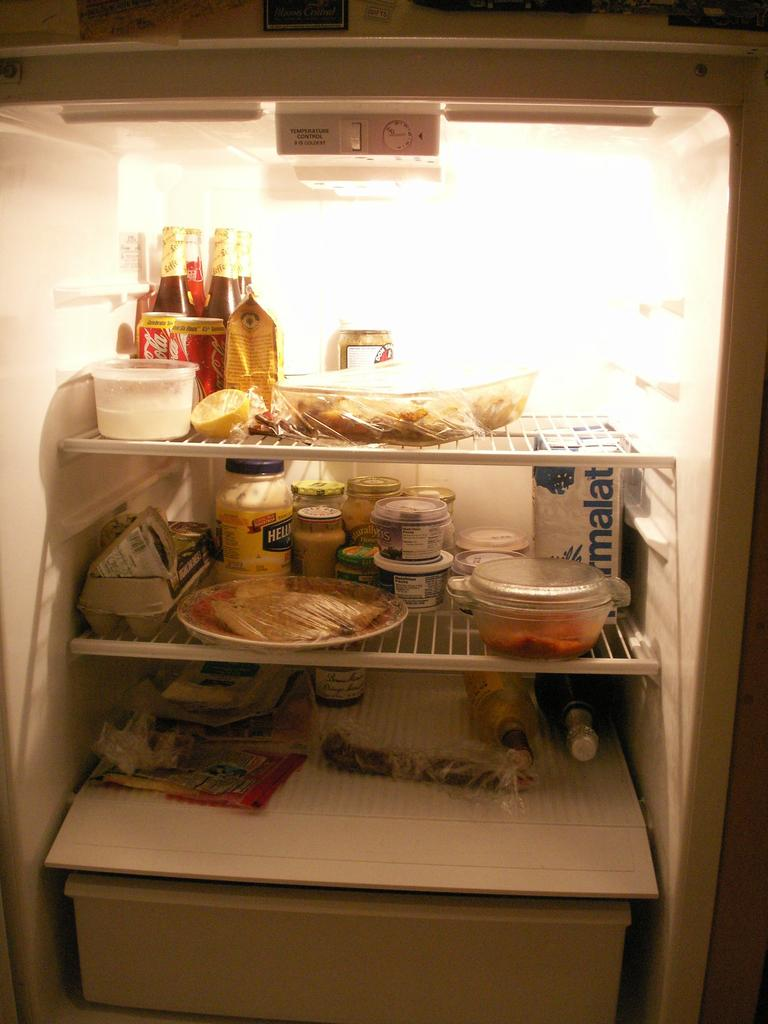<image>
Write a terse but informative summary of the picture. Coca Cola and Hellman's Mayonnaise, among other things, sit in a refrigerator. 